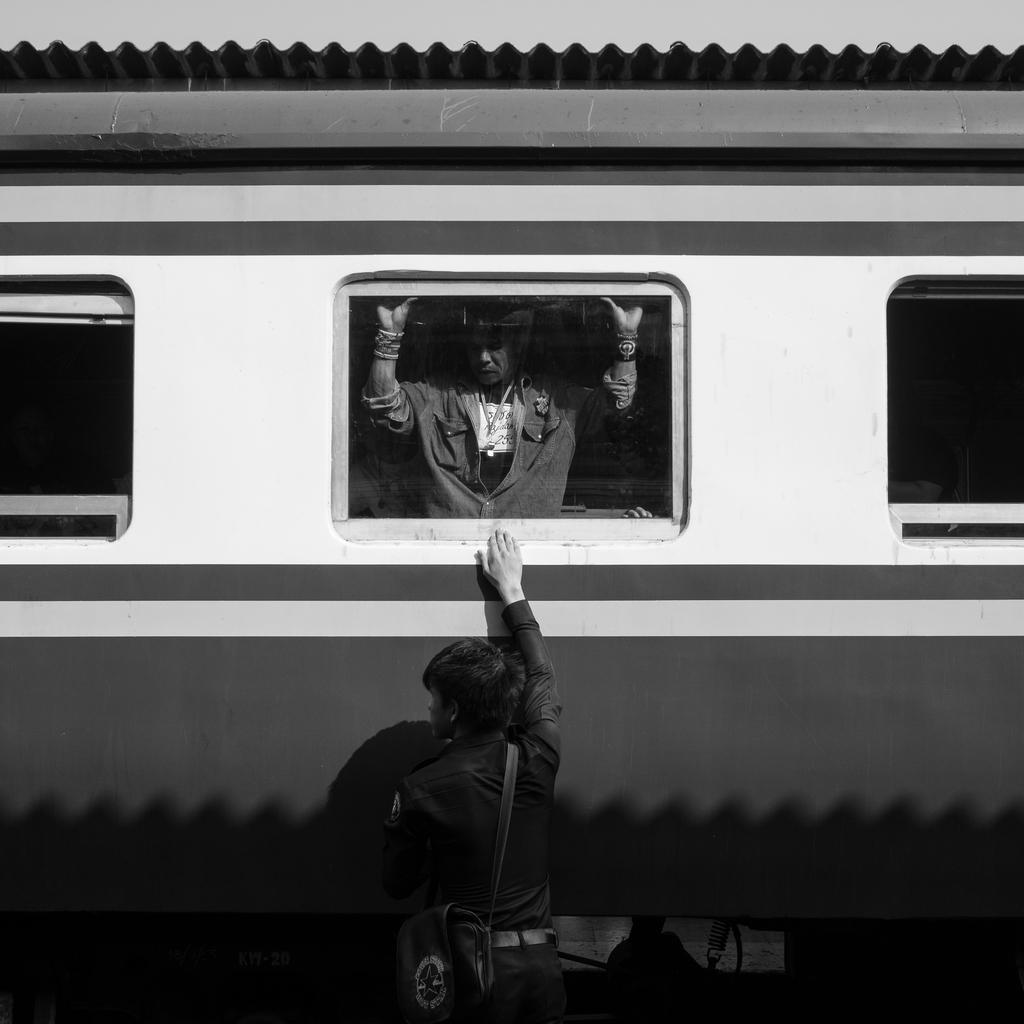Describe this image in one or two sentences. This is a black and white picture. I can see a person standing, there is another person standing inside the railway coach. 